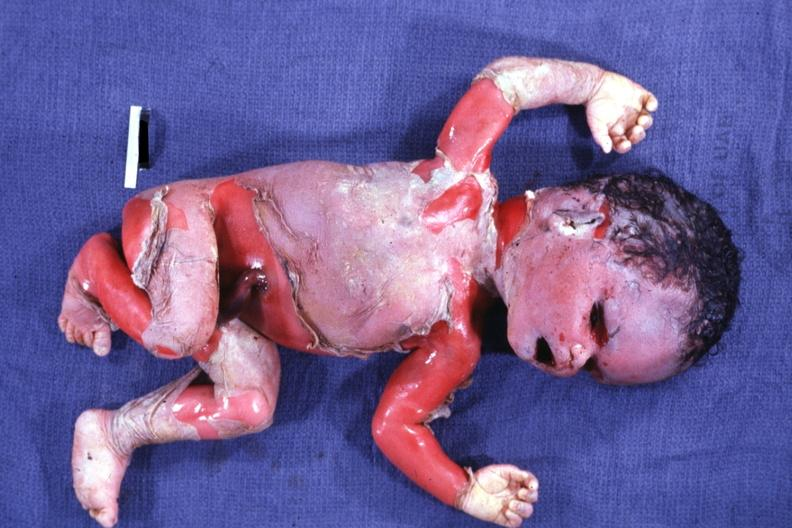s this image present?
Answer the question using a single word or phrase. No 